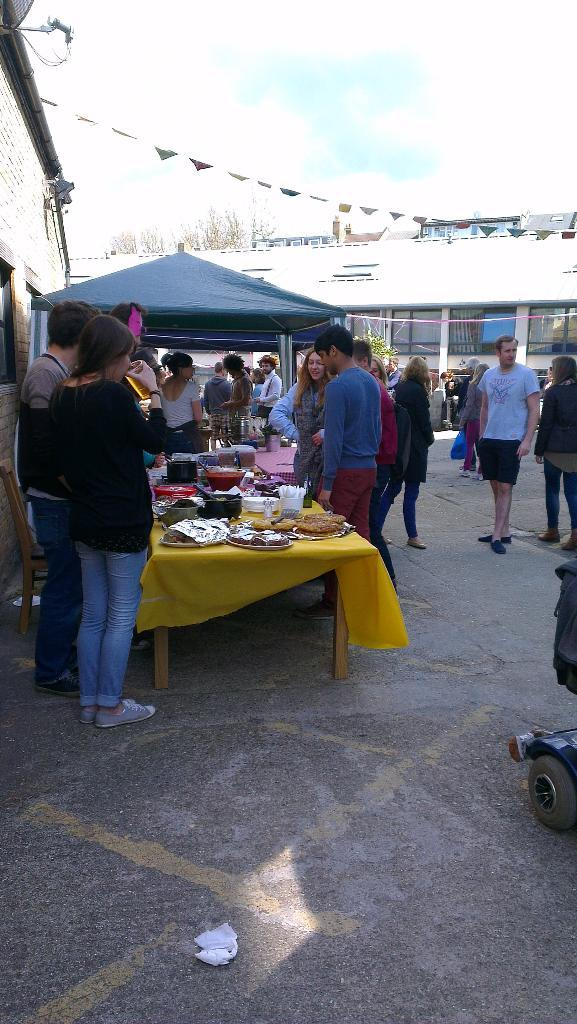What is happening in the image involving the people and the stall? There are many people standing near a stall in the image. What is located near the stall? There is a table near the stall. What can be seen in the background of the image? Buildings are visible in the image. How would you describe the weather based on the image? The sky is clear in the image, suggesting good weather. What type of linen is being sold at the stall in the image? There is no indication of any linen being sold at the stall in the image. Is there any poison visible in the image? There is no poison present in the image. 